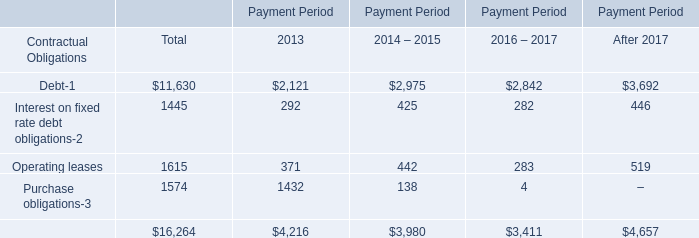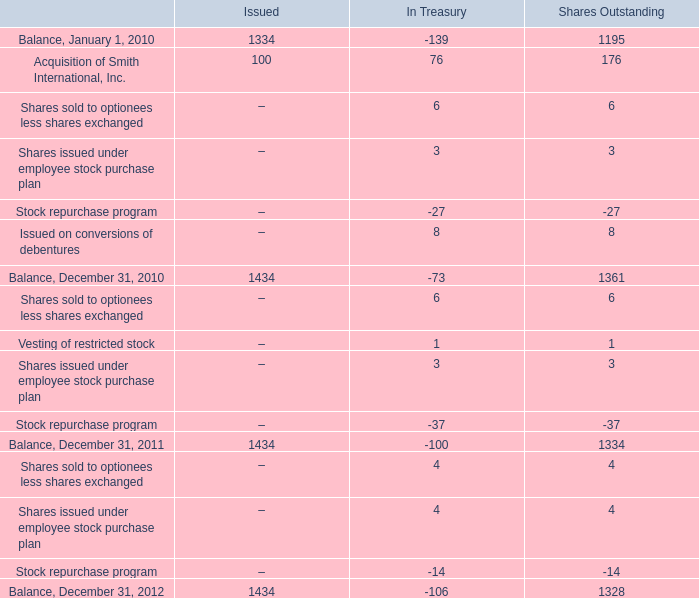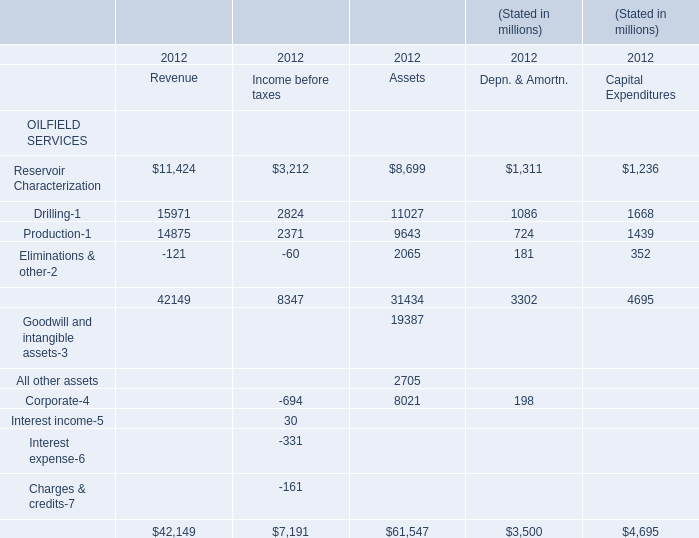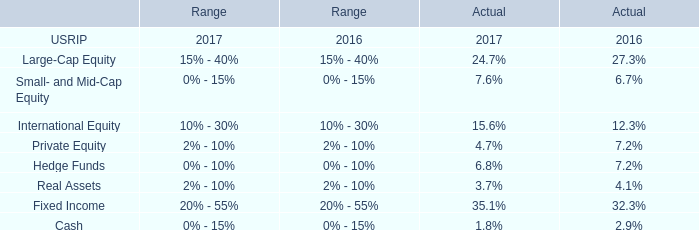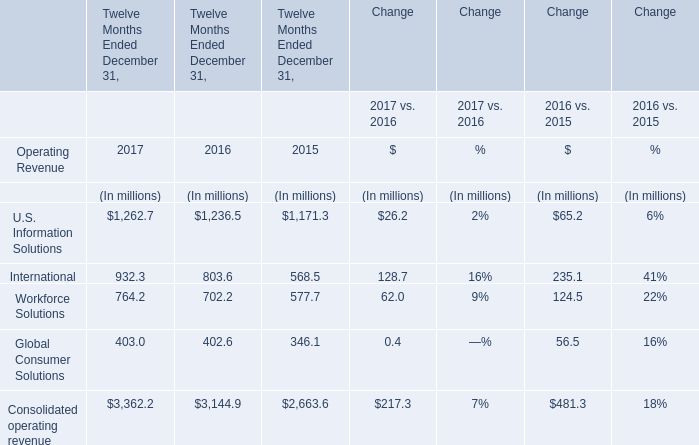What will International be like in 2018 if it develops with the same increasing rate as current? (in million) 
Computations: ((((932.3 - 803.6) / 803.6) + 1) * 932.3)
Answer: 1081.61186. 